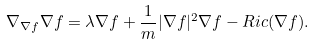Convert formula to latex. <formula><loc_0><loc_0><loc_500><loc_500>\nabla _ { \nabla f } \nabla f = \lambda \nabla f + \frac { 1 } { m } | \nabla f | ^ { 2 } \nabla f - R i c ( \nabla f ) .</formula> 